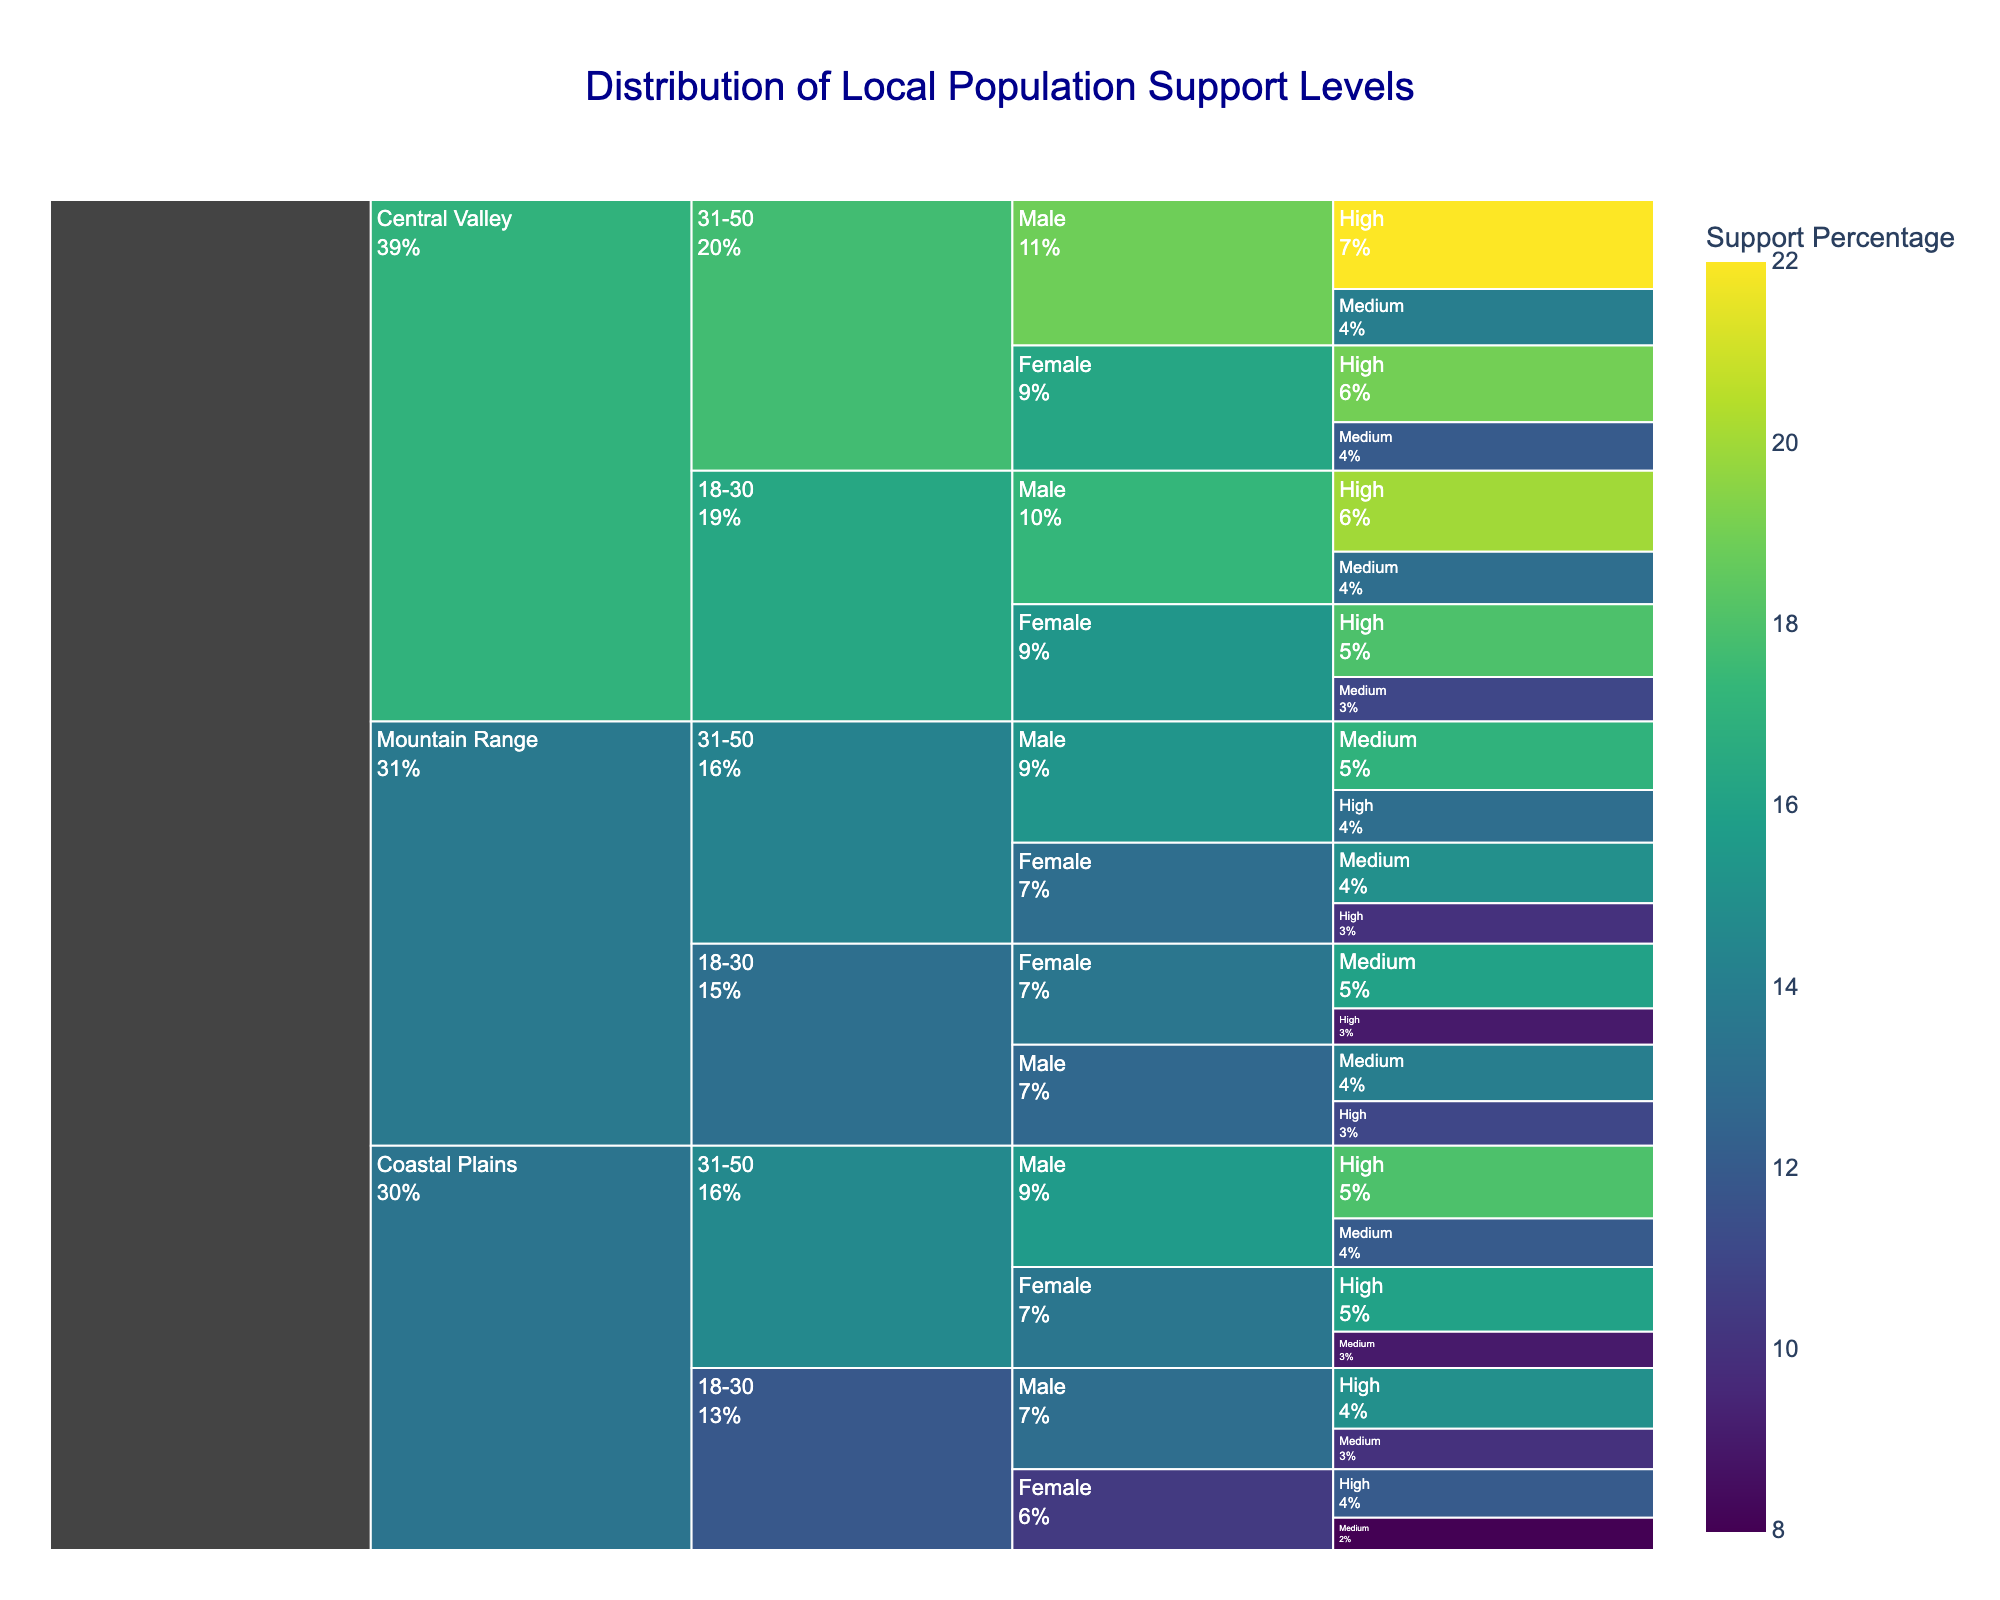Which region has the highest support level among males aged 18-30? By looking at the Icicle Chart, we can trace the pathway through Region -> Age Group -> Gender -> Support Level for males aged 18-30. The region with the highest value percentage-wise is the Central Valley, with the highest support for male 18-30 age group.
Answer: Central Valley What is the total percentage of high support in the Mountain Range region? In the Mountain Range region, the high support levels are: 11% (18-30 Male), 9% (18-30 Female), 13% (31-50 Male), and 10% (31-50 Female). Adding these up, we get 11 + 9 + 13 + 10 = 43%.
Answer: 43% Compare the percentage of high support between females aged 31-50 in Coastal Plains vs. Central Valley. Checking the pathways, Coastal Plains of female 31-50 show high support of 16%, whereas in Central Valley, it is 19%.
Answer: Central Valley has a higher percentage What is the average support percentage for medium support levels in the Central Valley region for both age groups? In Central Valley, medium support percentages are: 13% (18-30 Male), 11% (18-30 Female), 14% (31-50 Male), 12% (31-50 Female). The average is (13+11+14+12)/4 = 12.5%.
Answer: 12.5% Which gender and age group have the lowest percentage of high support in the Coastal Plains region? In the Coastal Plains, looking at high support percentages, it is lowest for females aged 18-30 at 12%.
Answer: Female, 18-30 How does the support level distribution differ between 18-30 and 31-50 age groups in the Mountain Range region? In Mountain Range, males aged 18-30 have 11% high and 14% medium, while females aged 18-30 have 9% high and 16% medium. For the 31-50 age group, males have 13% high and 17% medium, and females have 10% high and 15% medium.
Answer: 31-50 age group has higher medium support percentages If the total population in the Mountain Range region is equally split among all demographic sub-groups considered, what’s the weighted average support level (in terms of high support) across all gender and age combinations? There's equal population for each sub-group. High support percentages in Mountain Range are: 11% (18-30 Male), 9% (18-30 Female), 13% (31-50 Male), 10% (31-50 Female). The weighted average would be (11+9+13+10)/4 = 10.75%.
Answer: 10.75% Identify the most supportive demographic group in the Coastal Plains region. Coastal Plains high support: 15% (18-30 Male), 12% (18-30 Female), 18% (31-50 Male), 16% (31-50 Female). The highest percentage is 31-50 Male with 18%.
Answer: Males aged 31-50 